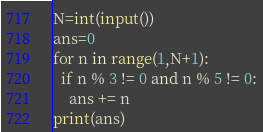<code> <loc_0><loc_0><loc_500><loc_500><_Python_>N=int(input())
ans=0
for n in range(1,N+1):
  if n % 3 != 0 and n % 5 != 0:
    ans += n
print(ans)</code> 